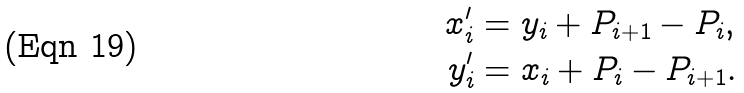Convert formula to latex. <formula><loc_0><loc_0><loc_500><loc_500>x _ { i } ^ { \prime } & = y _ { i } + P _ { i + 1 } - P _ { i } , \\ y _ { i } ^ { \prime } & = x _ { i } + P _ { i } - P _ { i + 1 } .</formula> 